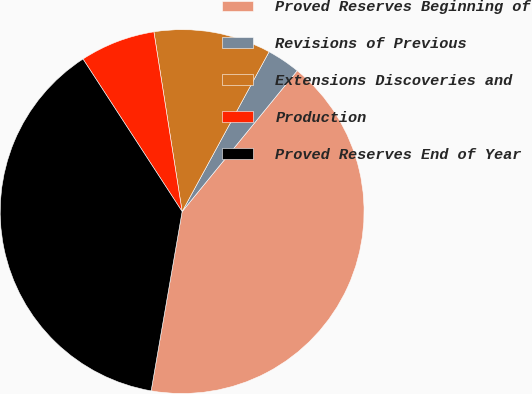Convert chart. <chart><loc_0><loc_0><loc_500><loc_500><pie_chart><fcel>Proved Reserves Beginning of<fcel>Revisions of Previous<fcel>Extensions Discoveries and<fcel>Production<fcel>Proved Reserves End of Year<nl><fcel>41.82%<fcel>2.97%<fcel>10.41%<fcel>6.69%<fcel>38.1%<nl></chart> 